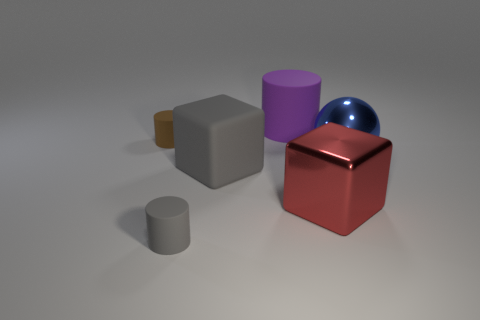What number of purple rubber cylinders are the same size as the metallic cube?
Make the answer very short. 1. Is the size of the cylinder in front of the big blue thing the same as the block that is on the right side of the purple thing?
Provide a succinct answer. No. What number of things are either large purple metal objects or large things that are behind the tiny brown thing?
Provide a short and direct response. 1. What color is the big matte cube?
Ensure brevity in your answer.  Gray. What material is the large block that is in front of the big object that is on the left side of the matte thing behind the brown rubber object made of?
Give a very brief answer. Metal. What is the size of the gray cube that is the same material as the tiny brown thing?
Provide a short and direct response. Large. Are there any small matte objects that have the same color as the large sphere?
Provide a succinct answer. No. Is the size of the purple matte thing the same as the gray rubber thing that is in front of the metallic block?
Offer a terse response. No. There is a matte object that is in front of the shiny thing to the left of the metal sphere; how many brown things are on the left side of it?
Your answer should be very brief. 1. The thing that is the same color as the large matte cube is what size?
Provide a short and direct response. Small. 